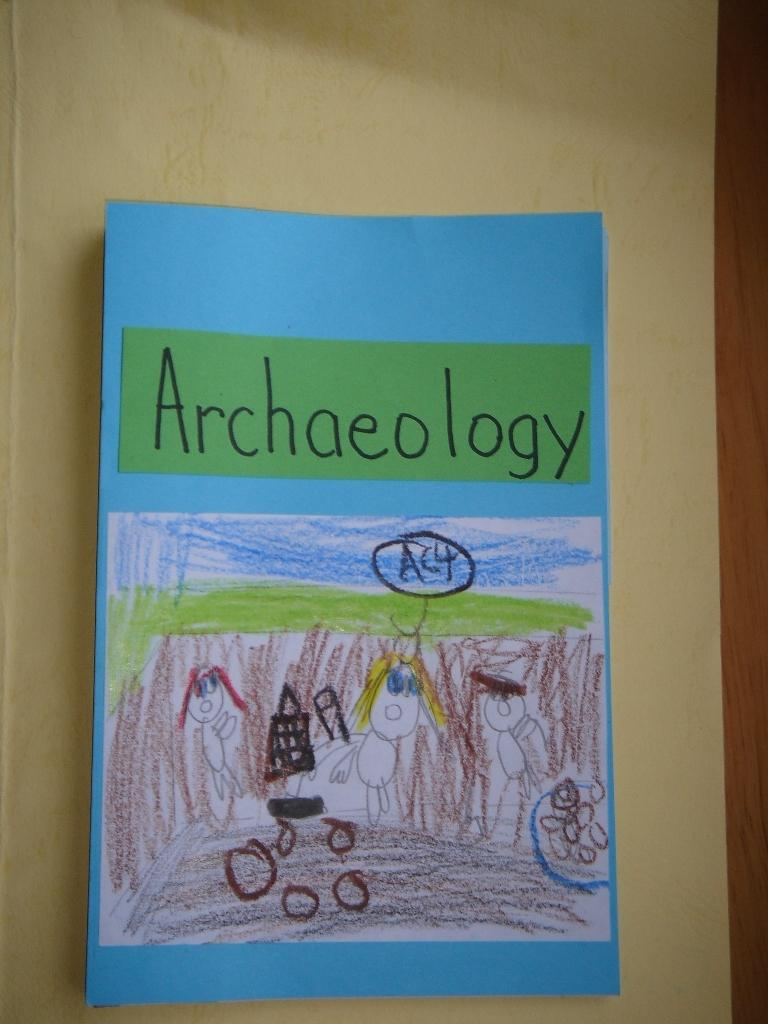What object can be seen in the image? There is a book in the image. Where is the book located? The book is on a wooden table. What can be seen on the cover of the book? There is a drawing on the cover of the book. How many geese are flying over the book in the image? There are no geese present in the image; it only features a book on a wooden table with a drawing on its cover. 